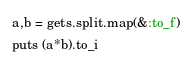Convert code to text. <code><loc_0><loc_0><loc_500><loc_500><_Ruby_>a,b = gets.split.map(&:to_f)
puts (a*b).to_i</code> 